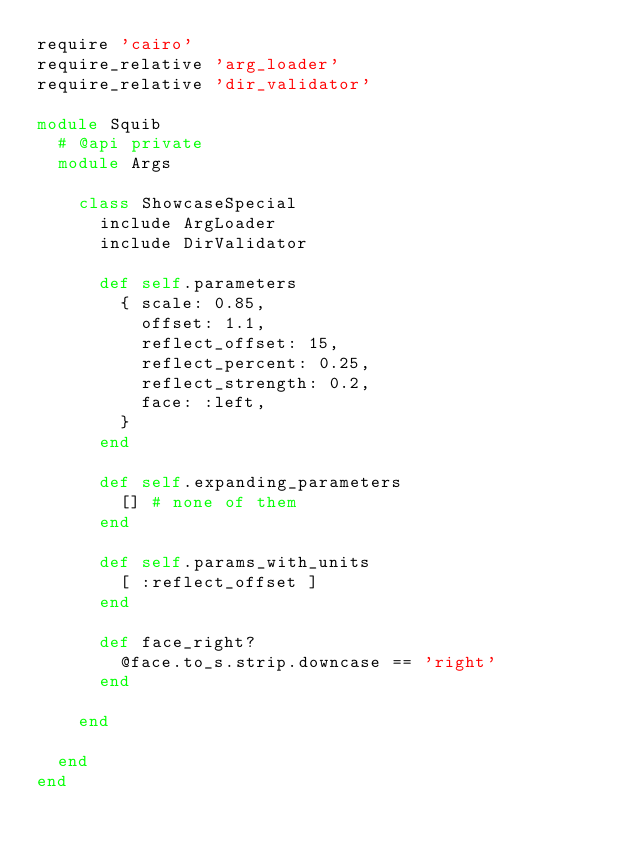Convert code to text. <code><loc_0><loc_0><loc_500><loc_500><_Ruby_>require 'cairo'
require_relative 'arg_loader'
require_relative 'dir_validator'

module Squib
  # @api private
  module Args

    class ShowcaseSpecial
      include ArgLoader
      include DirValidator

      def self.parameters
        { scale: 0.85,
          offset: 1.1,
          reflect_offset: 15,
          reflect_percent: 0.25,
          reflect_strength: 0.2,
          face: :left,
        }
      end

      def self.expanding_parameters
        [] # none of them
      end

      def self.params_with_units
        [ :reflect_offset ]
      end

      def face_right?
        @face.to_s.strip.downcase == 'right'
      end

    end

  end
end
</code> 